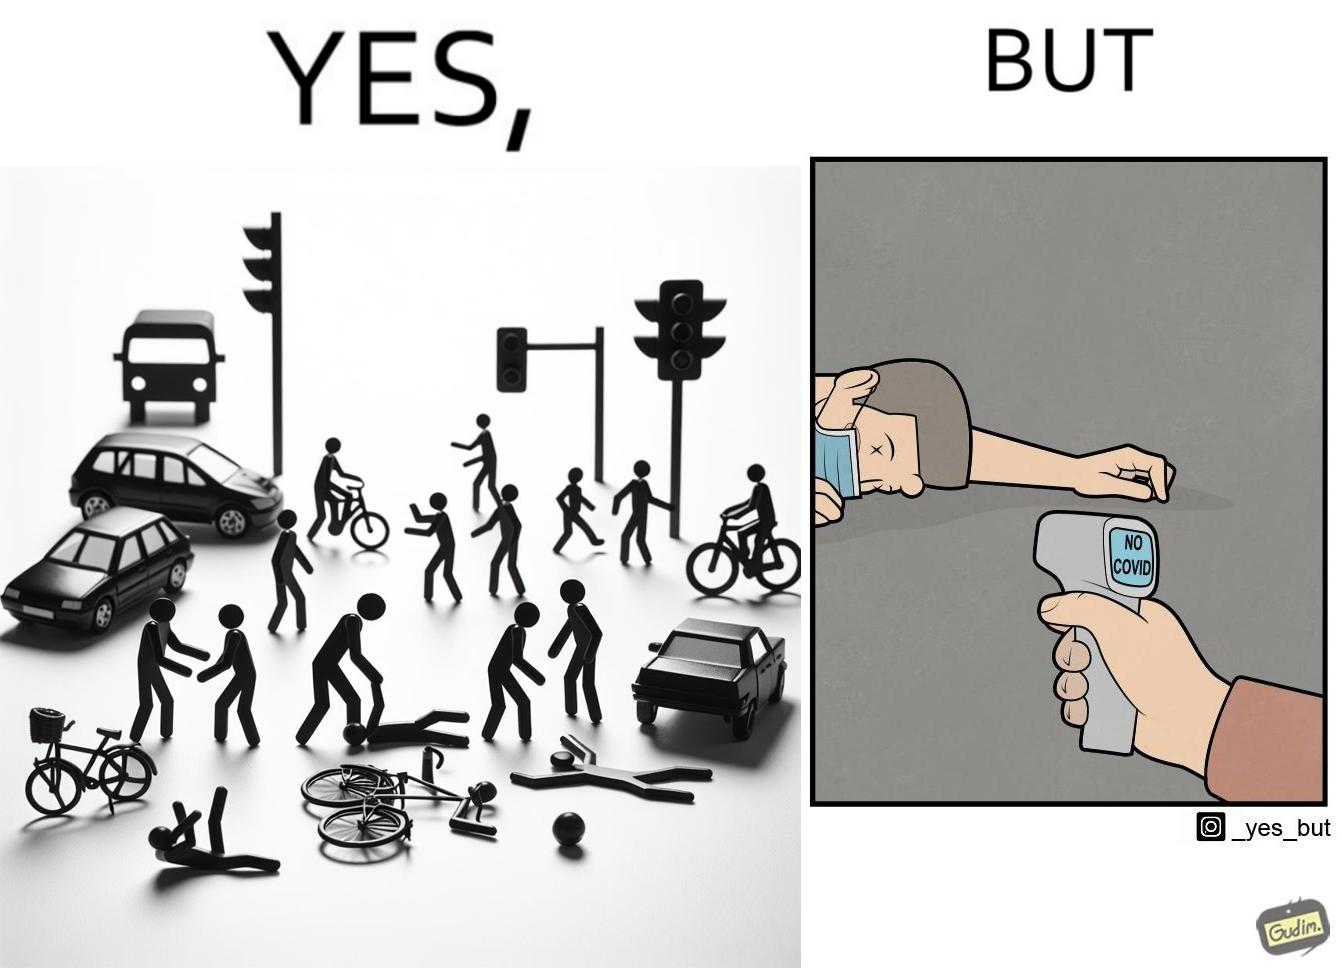Is this a satirical image? Yes, this image is satirical. 